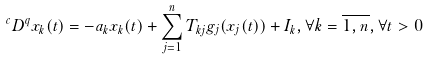<formula> <loc_0><loc_0><loc_500><loc_500>^ { c } D ^ { q } x _ { k } ( t ) = - a _ { k } x _ { k } ( t ) + \sum _ { j = 1 } ^ { n } T _ { k j } g _ { j } ( x _ { j } ( t ) ) + I _ { k } , \forall k = \overline { 1 , n } , \forall t > 0</formula> 